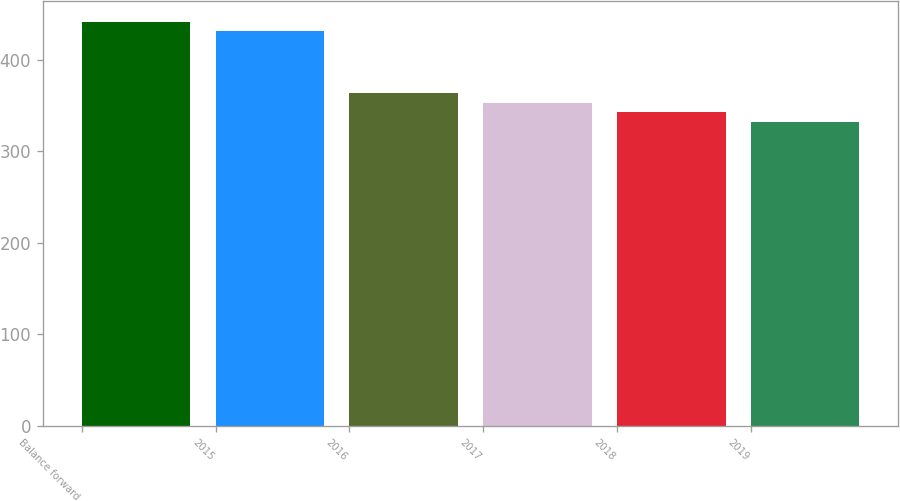<chart> <loc_0><loc_0><loc_500><loc_500><bar_chart><fcel>Balance forward<fcel>2015<fcel>2016<fcel>2017<fcel>2018<fcel>2019<nl><fcel>441.6<fcel>431<fcel>363.8<fcel>353.2<fcel>342.6<fcel>332<nl></chart> 